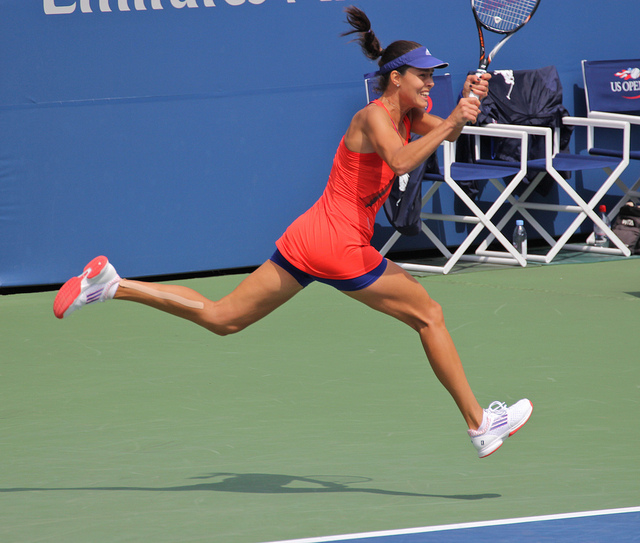<image>How much time is left? It is unknown how much time is left. It could be anywhere from 0 to 10 minutes. How much time is left? I don't know how much time is left. It can be either 0, 5 minutes, 2 minutes, 10 minutes, or 1 minute. 